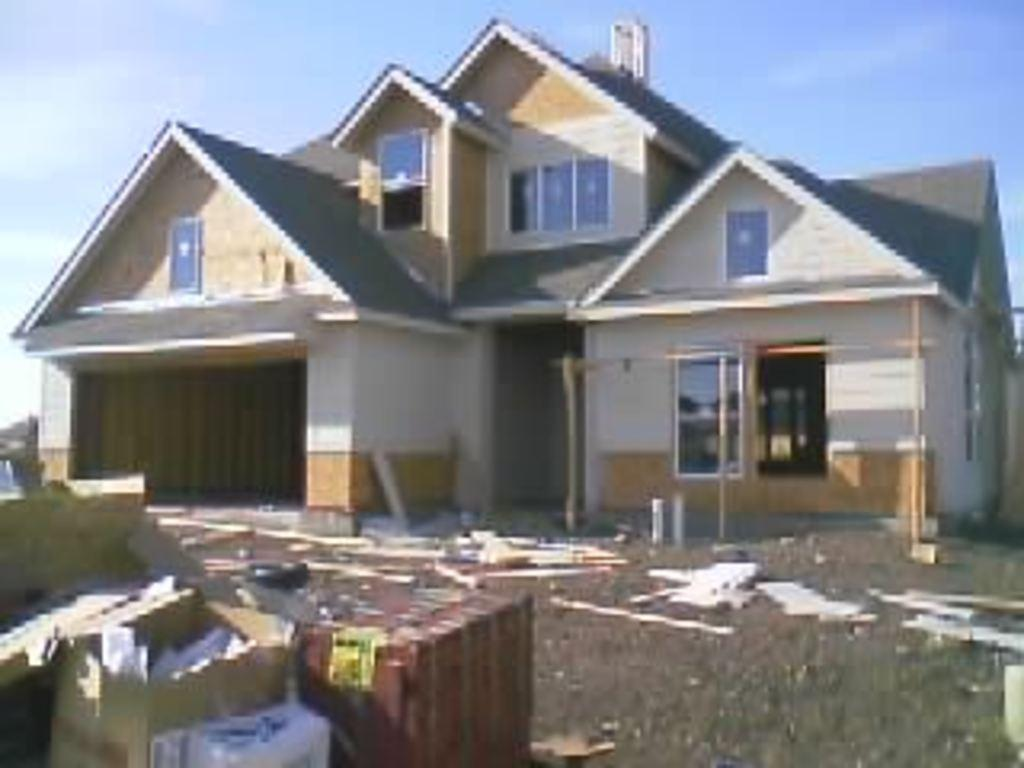What objects are on the left side of the image? There are cartons and other items on the left side of the image. What can be seen in the background of the image? There is a building in the background of the image. What type of juice can be seen in the image? There is no juice present in the image; it only shows cartons and other items on the left side and a building in the background. What reason might someone have for placing the cartons in the image? The image does not provide any information about the reason for placing the cartons, as it only shows their presence and the building in the background. 